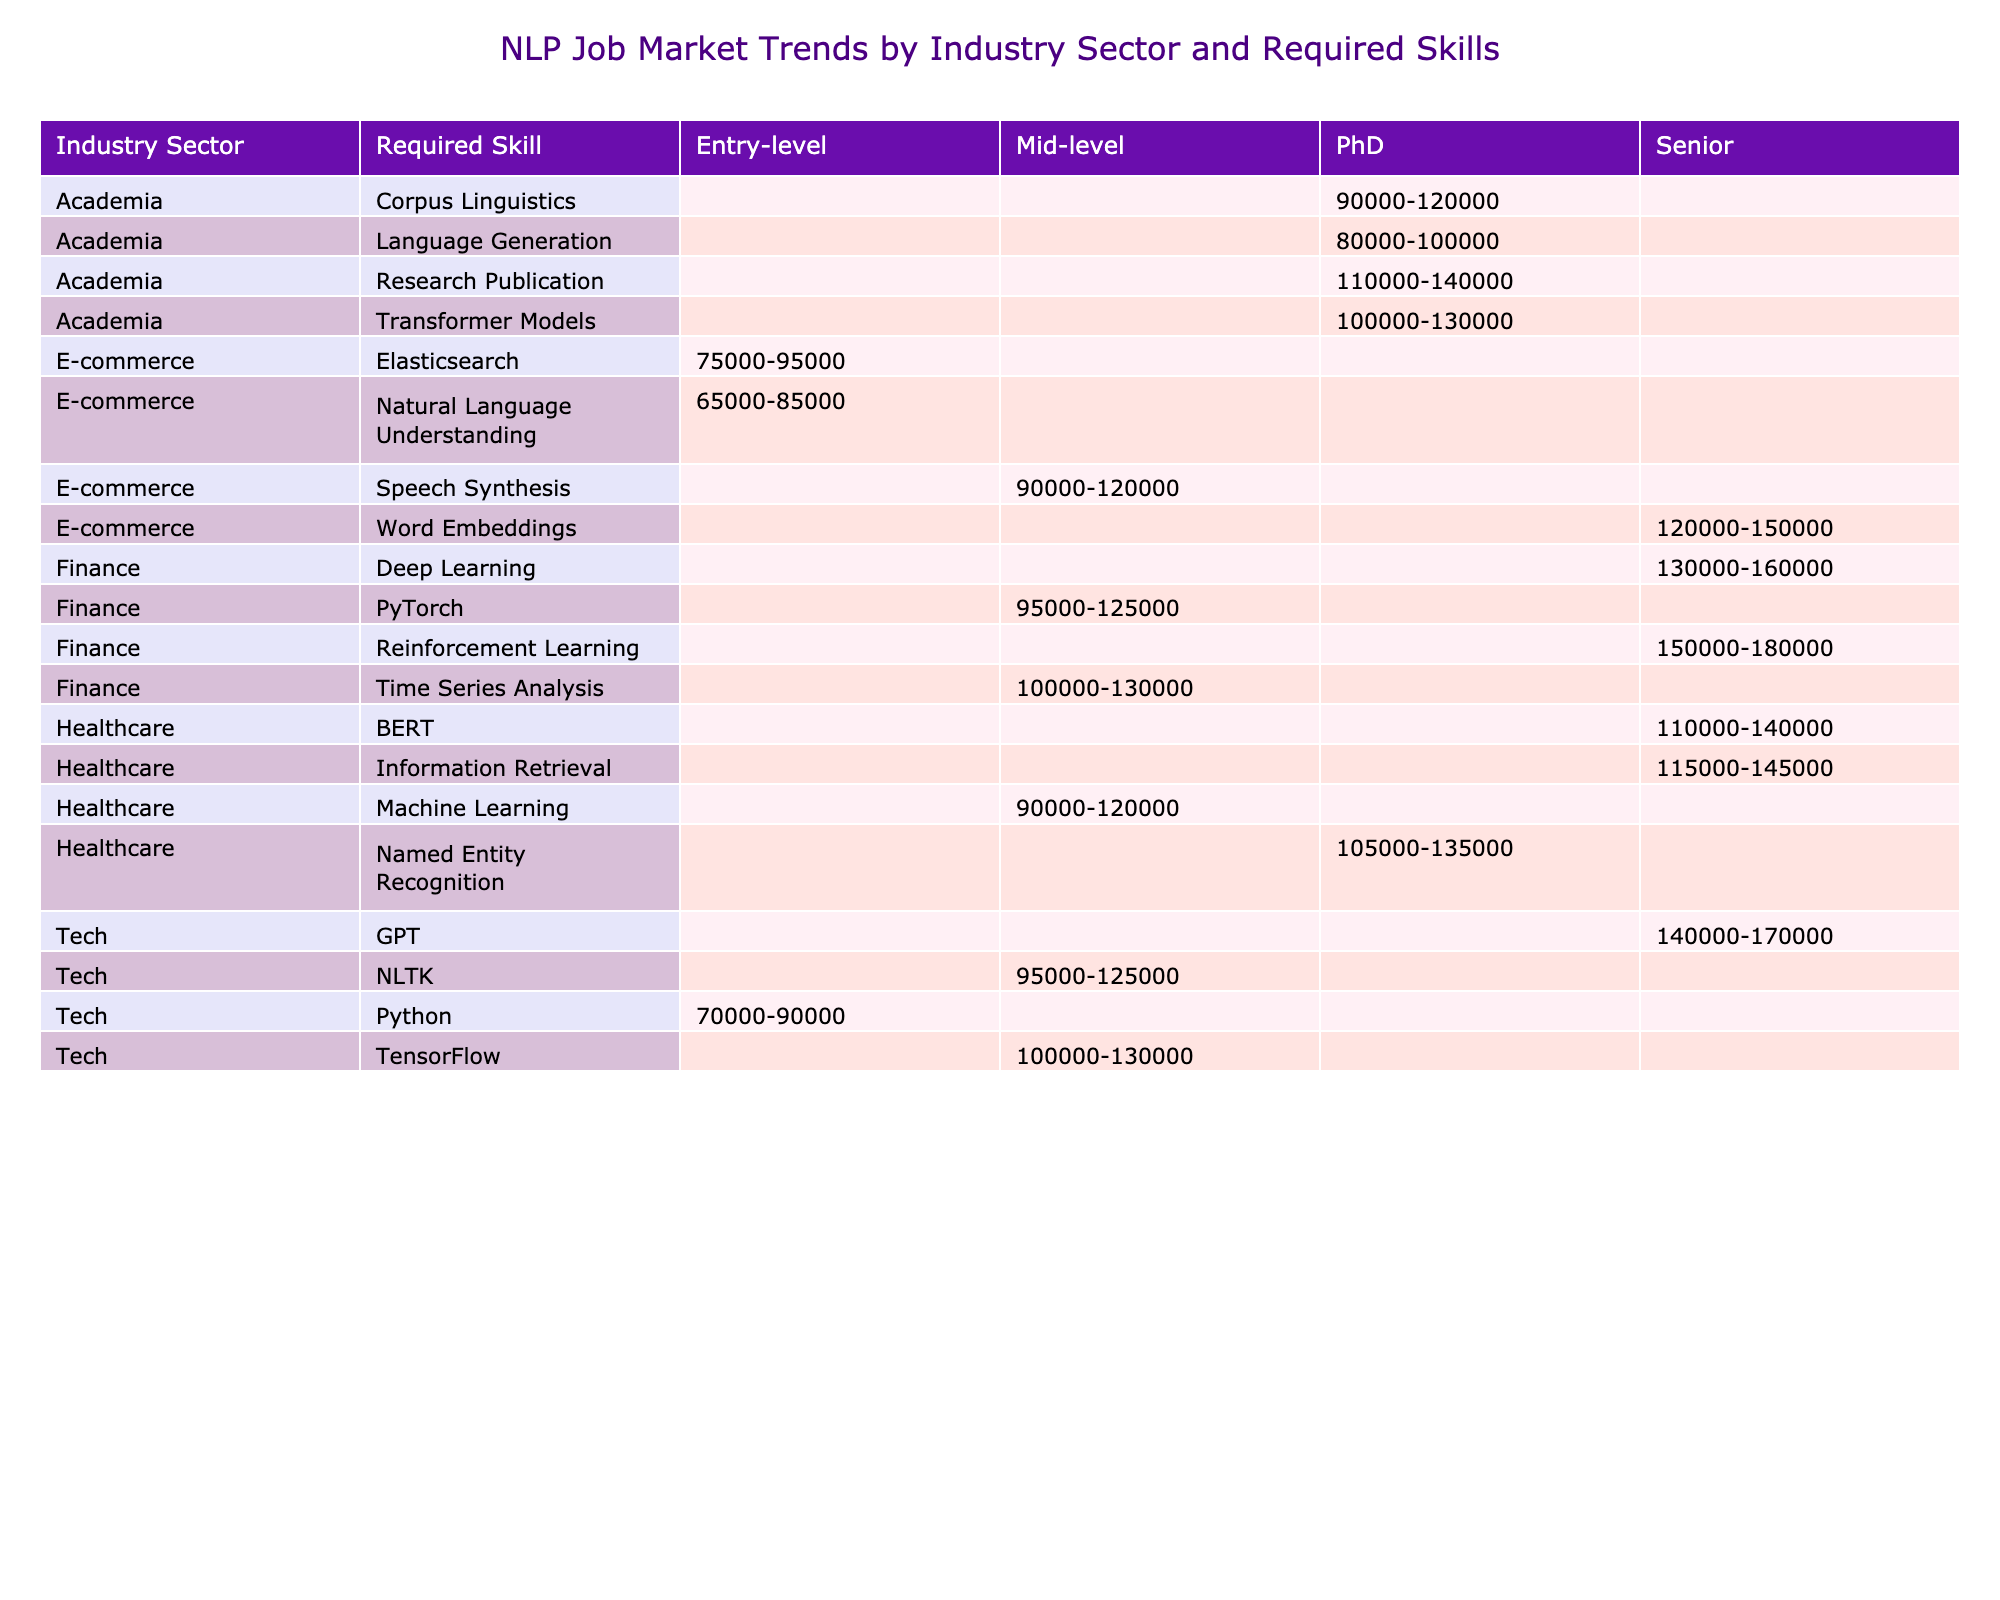What's the highest salary range for a job in the tech sector? The tech sector has several job titles listed, including NLP Engineer, Speech Recognition Engineer, Language Model Engineer, and Multilingual NLP Engineer. The highest salary range from these roles is for the Language Model Engineer, which is 140000-170000.
Answer: 140000-170000 Which required skill is associated with the highest salary in the finance sector? In the finance sector, the roles mentioned are Sentiment Analysis Expert, NLP Data Scientist, Quantitative NLP Analyst, and NLP Trading Strategist. The NLP Trading Strategist, which requires Reinforcement Learning, has the highest salary range of 150000-180000.
Answer: Reinforcement Learning How many mid-level positions are there in the healthcare sector? The healthcare sector lists three positions: Clinical NLP Specialist and Medical Language Processing Analyst as mid-level, and Health Information Extraction Specialist is marked as Senior. Therefore, there are two mid-level positions in healthcare.
Answer: 2 Is there any entry-level job in academia? The table indicates there are two academia roles: Research Scientist and NLP Professor which require a PhD and are not entry-level. However, the NLP Postdoctoral Researcher is also listed, which although it's intended for recent PhD graduates, isn't classified explicitly as an entry-level position. Thus, the statement is false as no explicit entry-level job is present.
Answer: No What is the average salary range for senior positions in e-commerce? The e-commerce sector lists three senior positions: Recommendation System Engineer, Chatbot Developer, and Voice Shopping Assistant Developer. The corresponding salary ranges are 120000-150000, 65000-85000, and 90000-120000. To average these, we convert them into numerical ranges: (120000 + 150000) / 2 = 135000, (65000 + 85000) / 2 = 75000, and (90000 + 120000) / 2 = 105000. Computing the average of these three midpoint values (135000 + 75000 + 105000) / 3 gives us 105000. The average salary is reflecting as a range of 105000, considering the non-senior positions do not contribute this aspect.
Answer: 105000 What required skill is most common for entry-level jobs across all industries? The table highlights entry-level roles across various sectors: NLP Engineer (Python), Chatbot Developer (Natural Language Understanding), and Semantic Search Engineer (Elasticsearch). The unique required skills here are Python, Natural Language Understanding, and Elasticsearch. Since all are individually mentioned with no overlaps, the most common skill counts as one of each skill listed. Therefore, there's no predominant skill among them - each is equally represented in different job offerings.
Answer: None 